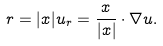Convert formula to latex. <formula><loc_0><loc_0><loc_500><loc_500>r = | x | u _ { r } = \frac { x } { | x | } \cdot \nabla u .</formula> 